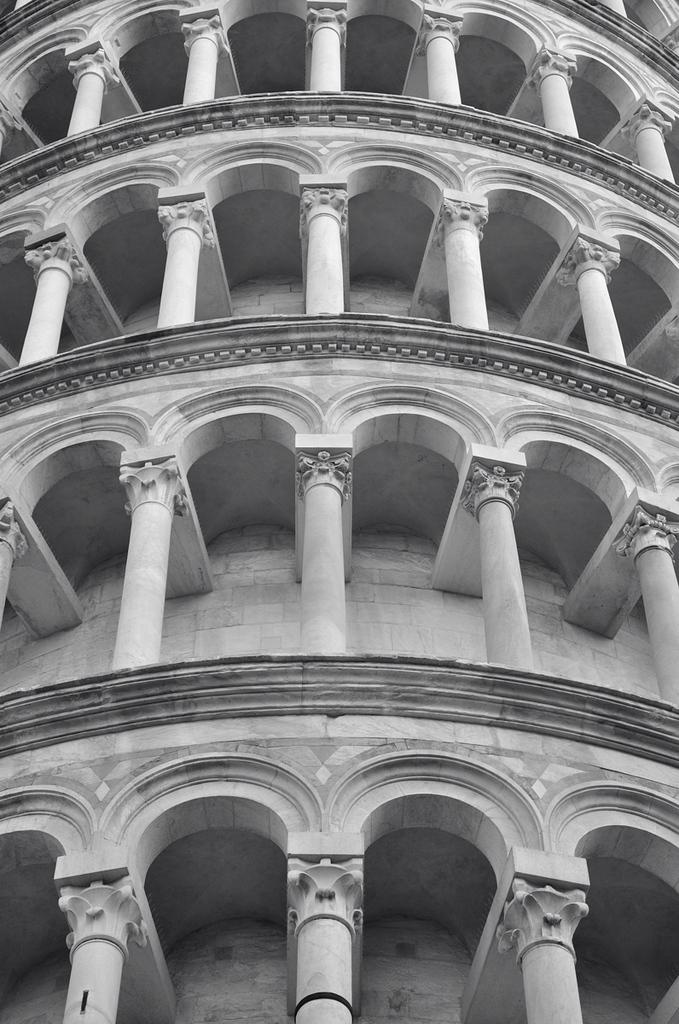What is the main subject of the image? The main subject of the image is a huge building. Can you describe the appearance of the building? The building is ash and black in color. What architectural features can be seen in the building? There are multiple pillars in the building. What type of creature is wearing a crown on top of the building in the image? There is no creature or crown present on top of the building in the image; it only features a huge, ash-colored building with multiple pillars. 